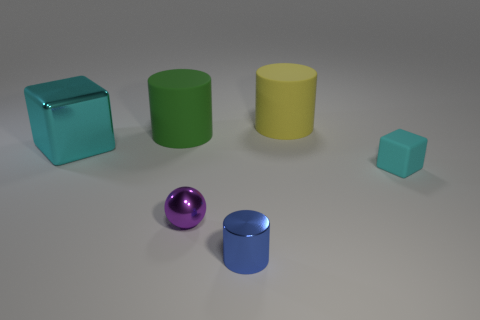Can you describe the shapes and colors of the objects on the table? Certainly! In the image, we see six objects with distinct shapes and colors. On the left, there's a transparent cyan cube and a solid green cylinder. In the center lies a reflective purple sphere next to a solid blue cylinder. On the right, there is a large opaque yellow cylinder and a smaller turquoise cube that appears solid. 